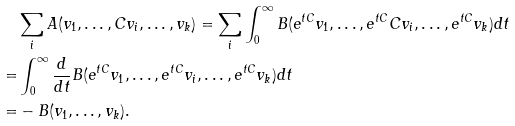<formula> <loc_0><loc_0><loc_500><loc_500>& \sum _ { i } A ( v _ { 1 } , \dots , C v _ { i } , \dots , v _ { k } ) = \sum _ { i } \int _ { 0 } ^ { \infty } B ( e ^ { t C } v _ { 1 } , \dots , e ^ { t C } C v _ { i } , \dots , e ^ { t C } v _ { k } ) d t \\ = & \int _ { 0 } ^ { \infty } \frac { d } { d t } B ( e ^ { t C } v _ { 1 } , \dots , e ^ { t C } v _ { i } , \dots , e ^ { t C } v _ { k } ) d t \\ = & - B ( v _ { 1 } , \dots , v _ { k } ) .</formula> 